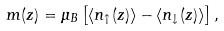<formula> <loc_0><loc_0><loc_500><loc_500>m ( z ) = \mu _ { B } \left [ \langle n _ { \uparrow } ( z ) \rangle - \langle n _ { \downarrow } ( z ) \rangle \right ] ,</formula> 